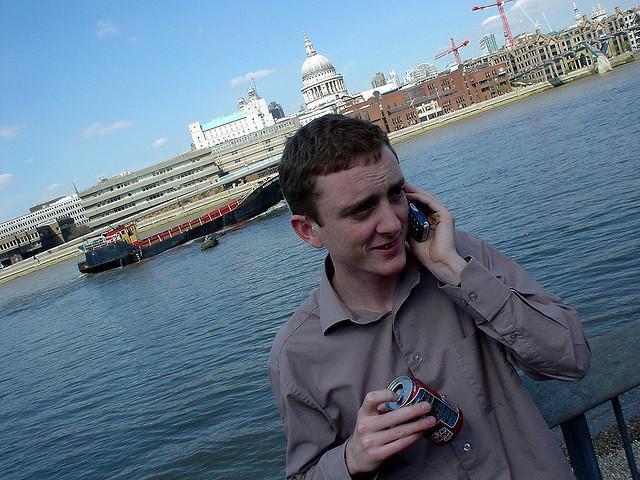How many people are in the photo?
Give a very brief answer. 1. How many people are pictured?
Give a very brief answer. 1. 